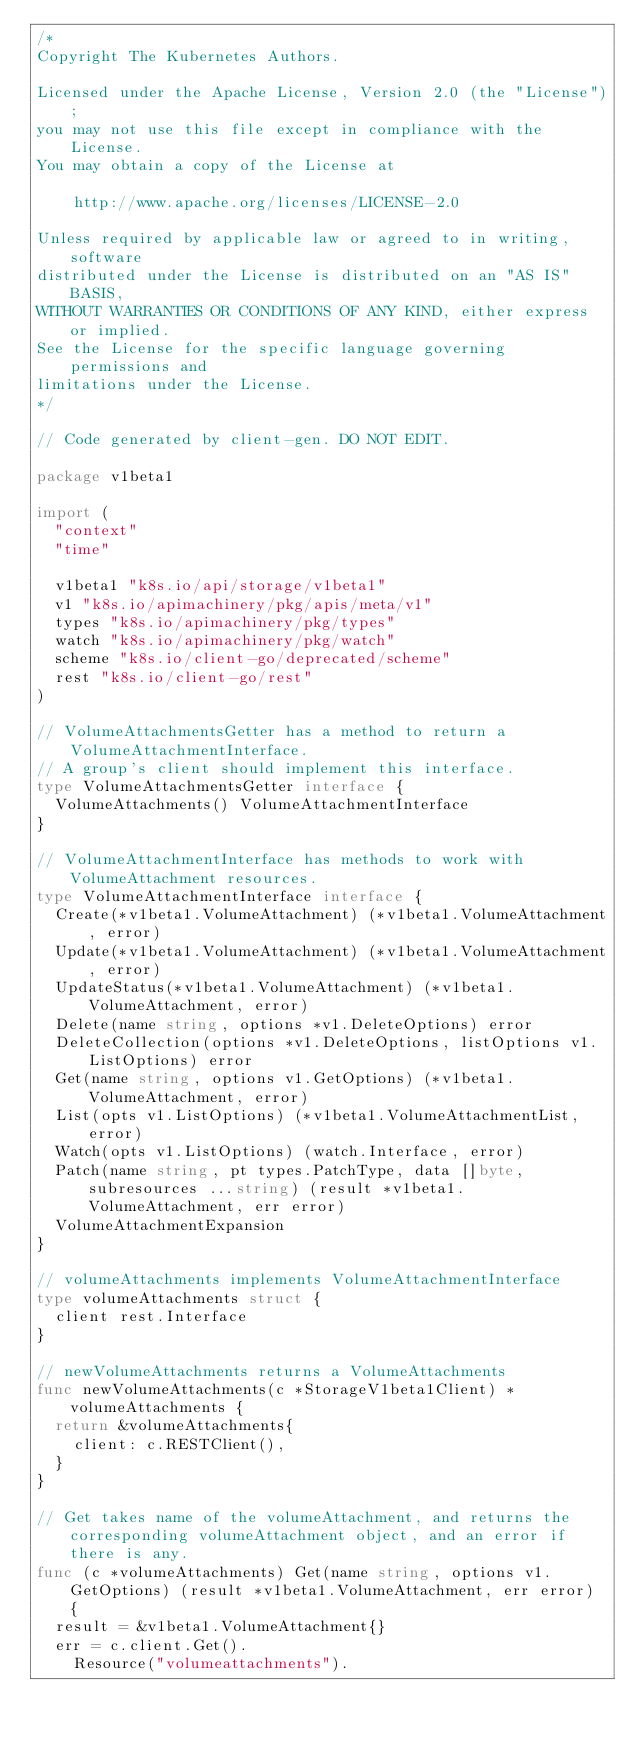<code> <loc_0><loc_0><loc_500><loc_500><_Go_>/*
Copyright The Kubernetes Authors.

Licensed under the Apache License, Version 2.0 (the "License");
you may not use this file except in compliance with the License.
You may obtain a copy of the License at

    http://www.apache.org/licenses/LICENSE-2.0

Unless required by applicable law or agreed to in writing, software
distributed under the License is distributed on an "AS IS" BASIS,
WITHOUT WARRANTIES OR CONDITIONS OF ANY KIND, either express or implied.
See the License for the specific language governing permissions and
limitations under the License.
*/

// Code generated by client-gen. DO NOT EDIT.

package v1beta1

import (
	"context"
	"time"

	v1beta1 "k8s.io/api/storage/v1beta1"
	v1 "k8s.io/apimachinery/pkg/apis/meta/v1"
	types "k8s.io/apimachinery/pkg/types"
	watch "k8s.io/apimachinery/pkg/watch"
	scheme "k8s.io/client-go/deprecated/scheme"
	rest "k8s.io/client-go/rest"
)

// VolumeAttachmentsGetter has a method to return a VolumeAttachmentInterface.
// A group's client should implement this interface.
type VolumeAttachmentsGetter interface {
	VolumeAttachments() VolumeAttachmentInterface
}

// VolumeAttachmentInterface has methods to work with VolumeAttachment resources.
type VolumeAttachmentInterface interface {
	Create(*v1beta1.VolumeAttachment) (*v1beta1.VolumeAttachment, error)
	Update(*v1beta1.VolumeAttachment) (*v1beta1.VolumeAttachment, error)
	UpdateStatus(*v1beta1.VolumeAttachment) (*v1beta1.VolumeAttachment, error)
	Delete(name string, options *v1.DeleteOptions) error
	DeleteCollection(options *v1.DeleteOptions, listOptions v1.ListOptions) error
	Get(name string, options v1.GetOptions) (*v1beta1.VolumeAttachment, error)
	List(opts v1.ListOptions) (*v1beta1.VolumeAttachmentList, error)
	Watch(opts v1.ListOptions) (watch.Interface, error)
	Patch(name string, pt types.PatchType, data []byte, subresources ...string) (result *v1beta1.VolumeAttachment, err error)
	VolumeAttachmentExpansion
}

// volumeAttachments implements VolumeAttachmentInterface
type volumeAttachments struct {
	client rest.Interface
}

// newVolumeAttachments returns a VolumeAttachments
func newVolumeAttachments(c *StorageV1beta1Client) *volumeAttachments {
	return &volumeAttachments{
		client: c.RESTClient(),
	}
}

// Get takes name of the volumeAttachment, and returns the corresponding volumeAttachment object, and an error if there is any.
func (c *volumeAttachments) Get(name string, options v1.GetOptions) (result *v1beta1.VolumeAttachment, err error) {
	result = &v1beta1.VolumeAttachment{}
	err = c.client.Get().
		Resource("volumeattachments").</code> 